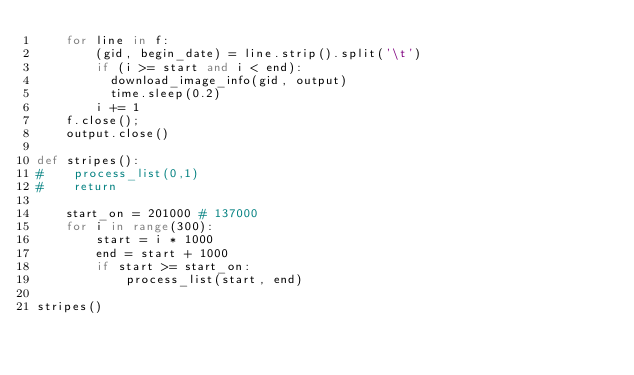<code> <loc_0><loc_0><loc_500><loc_500><_Python_>    for line in f:
        (gid, begin_date) = line.strip().split('\t')
        if (i >= start and i < end):
          download_image_info(gid, output)
          time.sleep(0.2)
        i += 1
    f.close();
    output.close()

def stripes():
#    process_list(0,1)
#    return

    start_on = 201000 # 137000
    for i in range(300):
        start = i * 1000
        end = start + 1000
        if start >= start_on:
            process_list(start, end)

stripes()
</code> 